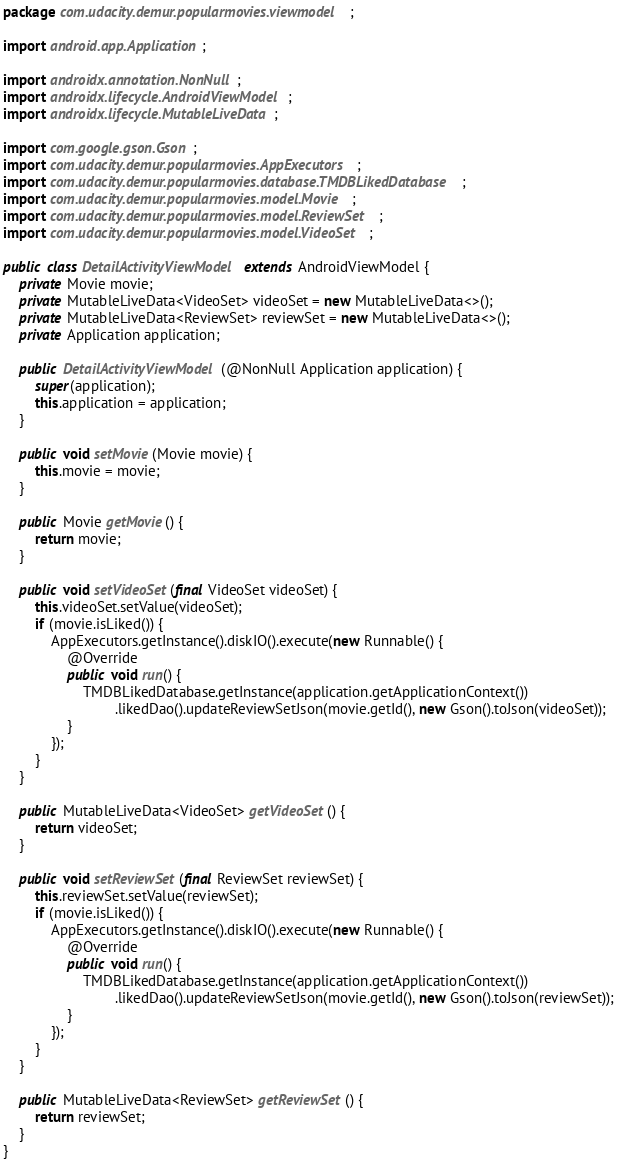Convert code to text. <code><loc_0><loc_0><loc_500><loc_500><_Java_>package com.udacity.demur.popularmovies.viewmodel;

import android.app.Application;

import androidx.annotation.NonNull;
import androidx.lifecycle.AndroidViewModel;
import androidx.lifecycle.MutableLiveData;

import com.google.gson.Gson;
import com.udacity.demur.popularmovies.AppExecutors;
import com.udacity.demur.popularmovies.database.TMDBLikedDatabase;
import com.udacity.demur.popularmovies.model.Movie;
import com.udacity.demur.popularmovies.model.ReviewSet;
import com.udacity.demur.popularmovies.model.VideoSet;

public class DetailActivityViewModel extends AndroidViewModel {
    private Movie movie;
    private MutableLiveData<VideoSet> videoSet = new MutableLiveData<>();
    private MutableLiveData<ReviewSet> reviewSet = new MutableLiveData<>();
    private Application application;

    public DetailActivityViewModel(@NonNull Application application) {
        super(application);
        this.application = application;
    }

    public void setMovie(Movie movie) {
        this.movie = movie;
    }

    public Movie getMovie() {
        return movie;
    }

    public void setVideoSet(final VideoSet videoSet) {
        this.videoSet.setValue(videoSet);
        if (movie.isLiked()) {
            AppExecutors.getInstance().diskIO().execute(new Runnable() {
                @Override
                public void run() {
                    TMDBLikedDatabase.getInstance(application.getApplicationContext())
                            .likedDao().updateReviewSetJson(movie.getId(), new Gson().toJson(videoSet));
                }
            });
        }
    }

    public MutableLiveData<VideoSet> getVideoSet() {
        return videoSet;
    }

    public void setReviewSet(final ReviewSet reviewSet) {
        this.reviewSet.setValue(reviewSet);
        if (movie.isLiked()) {
            AppExecutors.getInstance().diskIO().execute(new Runnable() {
                @Override
                public void run() {
                    TMDBLikedDatabase.getInstance(application.getApplicationContext())
                            .likedDao().updateReviewSetJson(movie.getId(), new Gson().toJson(reviewSet));
                }
            });
        }
    }

    public MutableLiveData<ReviewSet> getReviewSet() {
        return reviewSet;
    }
}</code> 